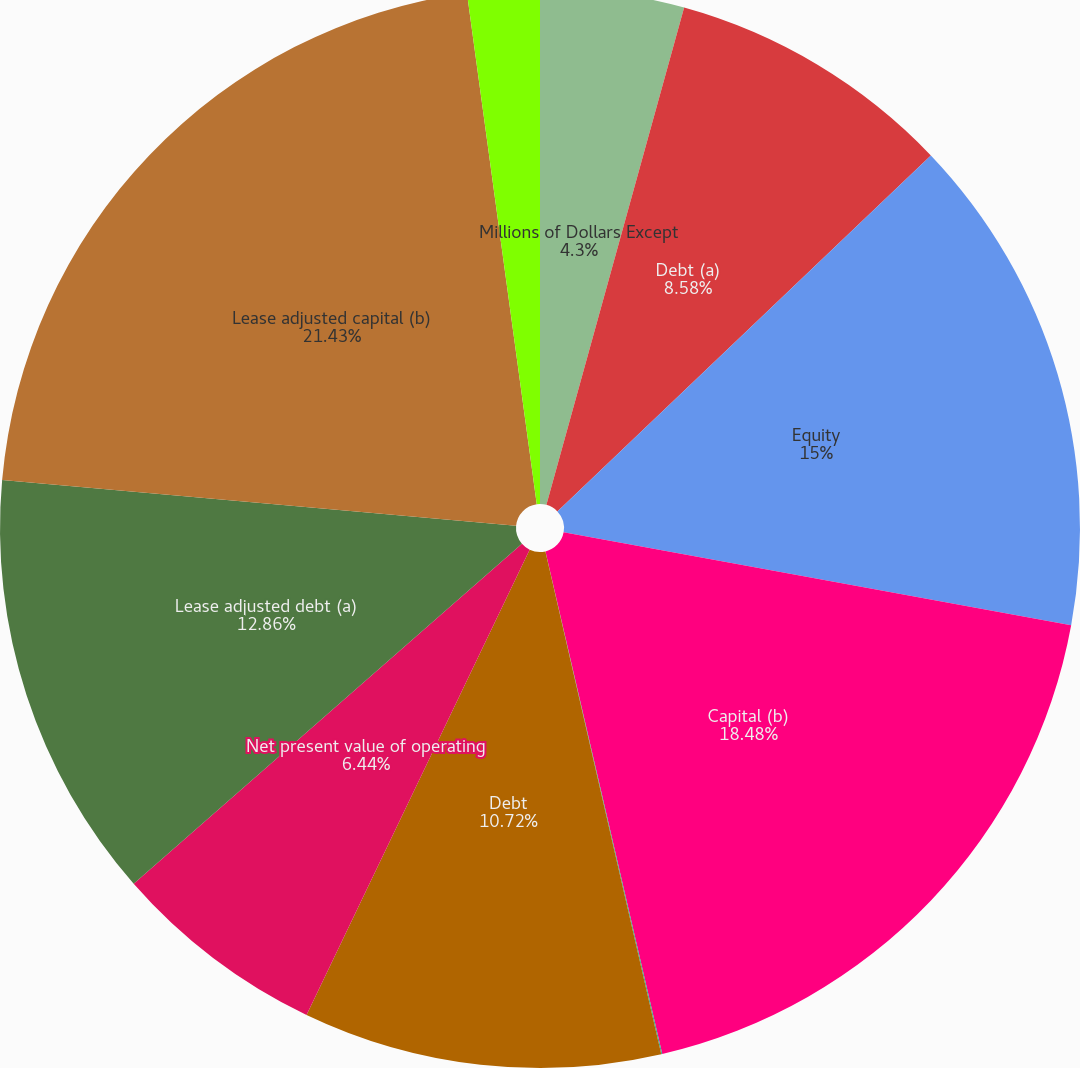Convert chart to OTSL. <chart><loc_0><loc_0><loc_500><loc_500><pie_chart><fcel>Millions of Dollars Except<fcel>Debt (a)<fcel>Equity<fcel>Capital (b)<fcel>Debt to capital (a/b)<fcel>Debt<fcel>Net present value of operating<fcel>Lease adjusted debt (a)<fcel>Lease adjusted capital (b)<fcel>Lease adjusted debt to capital<nl><fcel>4.3%<fcel>8.58%<fcel>15.0%<fcel>18.48%<fcel>0.03%<fcel>10.72%<fcel>6.44%<fcel>12.86%<fcel>21.42%<fcel>2.16%<nl></chart> 